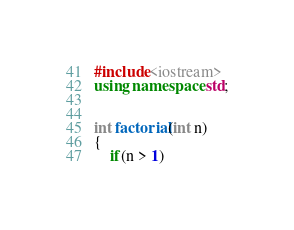Convert code to text. <code><loc_0><loc_0><loc_500><loc_500><_C++_>#include<iostream>
using namespace std;


int factorial(int n)
{
    if(n > 1)</code> 